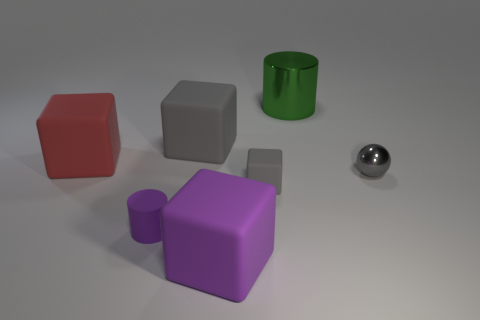There is a rubber thing that is both to the left of the big gray cube and behind the gray metallic sphere; what is its shape?
Make the answer very short. Cube. What is the size of the red thing that is the same shape as the large purple rubber thing?
Provide a short and direct response. Large. Are there fewer small gray rubber things that are in front of the big red thing than large red cubes?
Keep it short and to the point. No. How big is the gray thing that is behind the red object?
Your response must be concise. Large. What is the color of the small thing that is the same shape as the big red object?
Your response must be concise. Gray. How many big cubes are the same color as the metal sphere?
Ensure brevity in your answer.  1. Is there anything else that has the same shape as the tiny gray metal thing?
Your answer should be compact. No. There is a matte cube behind the large red rubber block that is in front of the large gray rubber cube; is there a cylinder on the left side of it?
Make the answer very short. Yes. How many other large cubes are made of the same material as the large gray block?
Provide a short and direct response. 2. There is a gray thing on the right side of the big green cylinder; does it have the same size as the cylinder behind the small purple thing?
Give a very brief answer. No. 